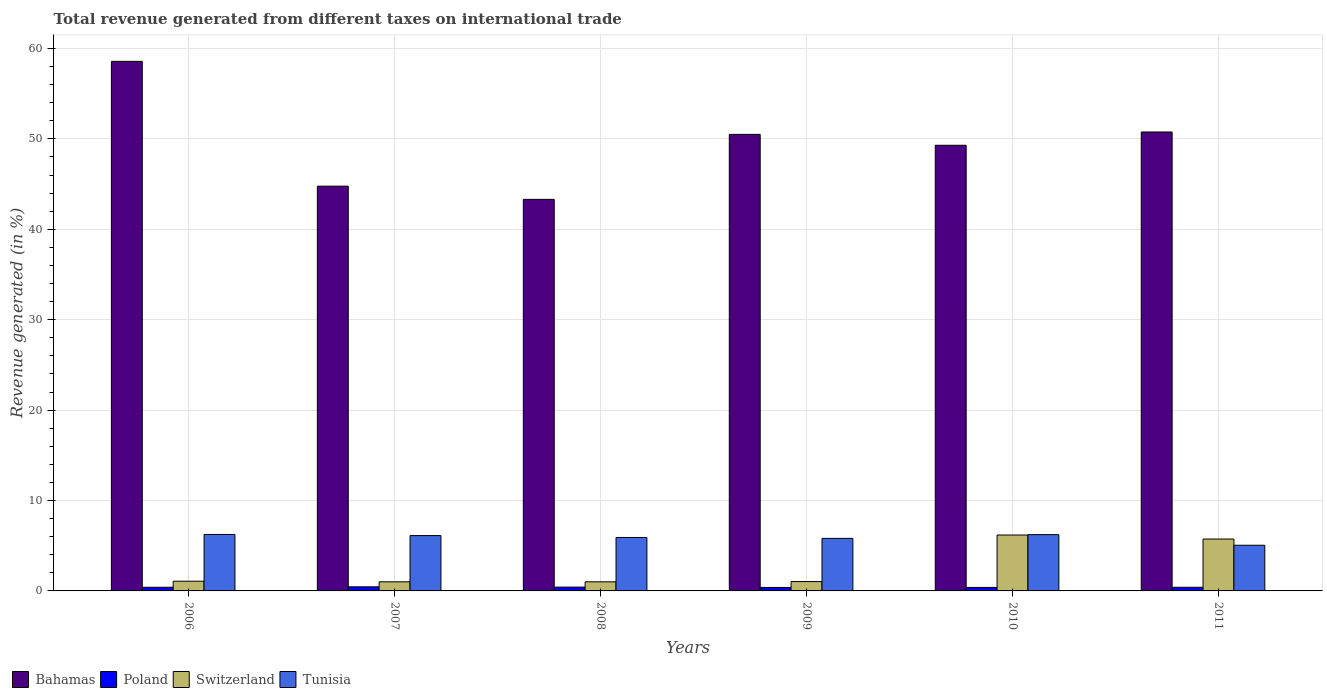How many groups of bars are there?
Your response must be concise. 6. What is the label of the 1st group of bars from the left?
Provide a short and direct response. 2006. In how many cases, is the number of bars for a given year not equal to the number of legend labels?
Give a very brief answer. 0. What is the total revenue generated in Switzerland in 2009?
Provide a succinct answer. 1.04. Across all years, what is the maximum total revenue generated in Bahamas?
Keep it short and to the point. 58.58. Across all years, what is the minimum total revenue generated in Bahamas?
Offer a very short reply. 43.31. In which year was the total revenue generated in Poland maximum?
Your response must be concise. 2007. In which year was the total revenue generated in Tunisia minimum?
Offer a terse response. 2011. What is the total total revenue generated in Poland in the graph?
Your answer should be very brief. 2.45. What is the difference between the total revenue generated in Bahamas in 2007 and that in 2008?
Your answer should be compact. 1.46. What is the difference between the total revenue generated in Bahamas in 2008 and the total revenue generated in Tunisia in 2010?
Keep it short and to the point. 37.09. What is the average total revenue generated in Bahamas per year?
Provide a succinct answer. 49.54. In the year 2009, what is the difference between the total revenue generated in Tunisia and total revenue generated in Switzerland?
Ensure brevity in your answer.  4.77. What is the ratio of the total revenue generated in Tunisia in 2010 to that in 2011?
Keep it short and to the point. 1.23. Is the total revenue generated in Poland in 2010 less than that in 2011?
Provide a short and direct response. Yes. What is the difference between the highest and the second highest total revenue generated in Poland?
Keep it short and to the point. 0.03. What is the difference between the highest and the lowest total revenue generated in Bahamas?
Offer a very short reply. 15.27. In how many years, is the total revenue generated in Switzerland greater than the average total revenue generated in Switzerland taken over all years?
Ensure brevity in your answer.  2. Is it the case that in every year, the sum of the total revenue generated in Switzerland and total revenue generated in Bahamas is greater than the sum of total revenue generated in Tunisia and total revenue generated in Poland?
Offer a very short reply. Yes. What does the 1st bar from the right in 2006 represents?
Keep it short and to the point. Tunisia. Is it the case that in every year, the sum of the total revenue generated in Tunisia and total revenue generated in Poland is greater than the total revenue generated in Bahamas?
Your answer should be compact. No. How many bars are there?
Your response must be concise. 24. Are all the bars in the graph horizontal?
Your response must be concise. No. How many years are there in the graph?
Your response must be concise. 6. What is the difference between two consecutive major ticks on the Y-axis?
Provide a short and direct response. 10. Are the values on the major ticks of Y-axis written in scientific E-notation?
Ensure brevity in your answer.  No. Does the graph contain grids?
Ensure brevity in your answer.  Yes. Where does the legend appear in the graph?
Your answer should be compact. Bottom left. How many legend labels are there?
Provide a short and direct response. 4. How are the legend labels stacked?
Keep it short and to the point. Horizontal. What is the title of the graph?
Provide a succinct answer. Total revenue generated from different taxes on international trade. What is the label or title of the Y-axis?
Your response must be concise. Revenue generated (in %). What is the Revenue generated (in %) in Bahamas in 2006?
Make the answer very short. 58.58. What is the Revenue generated (in %) of Poland in 2006?
Keep it short and to the point. 0.4. What is the Revenue generated (in %) in Switzerland in 2006?
Make the answer very short. 1.07. What is the Revenue generated (in %) in Tunisia in 2006?
Offer a terse response. 6.25. What is the Revenue generated (in %) of Bahamas in 2007?
Give a very brief answer. 44.77. What is the Revenue generated (in %) in Poland in 2007?
Provide a succinct answer. 0.45. What is the Revenue generated (in %) of Switzerland in 2007?
Ensure brevity in your answer.  1.01. What is the Revenue generated (in %) of Tunisia in 2007?
Make the answer very short. 6.12. What is the Revenue generated (in %) of Bahamas in 2008?
Provide a short and direct response. 43.31. What is the Revenue generated (in %) of Poland in 2008?
Your answer should be very brief. 0.42. What is the Revenue generated (in %) in Switzerland in 2008?
Your response must be concise. 1.01. What is the Revenue generated (in %) in Tunisia in 2008?
Your answer should be compact. 5.91. What is the Revenue generated (in %) of Bahamas in 2009?
Make the answer very short. 50.5. What is the Revenue generated (in %) in Poland in 2009?
Offer a terse response. 0.38. What is the Revenue generated (in %) in Switzerland in 2009?
Keep it short and to the point. 1.04. What is the Revenue generated (in %) in Tunisia in 2009?
Provide a succinct answer. 5.81. What is the Revenue generated (in %) in Bahamas in 2010?
Offer a terse response. 49.29. What is the Revenue generated (in %) in Poland in 2010?
Ensure brevity in your answer.  0.39. What is the Revenue generated (in %) in Switzerland in 2010?
Offer a terse response. 6.18. What is the Revenue generated (in %) of Tunisia in 2010?
Ensure brevity in your answer.  6.23. What is the Revenue generated (in %) in Bahamas in 2011?
Offer a terse response. 50.76. What is the Revenue generated (in %) of Poland in 2011?
Your response must be concise. 0.4. What is the Revenue generated (in %) in Switzerland in 2011?
Offer a very short reply. 5.74. What is the Revenue generated (in %) in Tunisia in 2011?
Keep it short and to the point. 5.05. Across all years, what is the maximum Revenue generated (in %) in Bahamas?
Your response must be concise. 58.58. Across all years, what is the maximum Revenue generated (in %) in Poland?
Offer a very short reply. 0.45. Across all years, what is the maximum Revenue generated (in %) in Switzerland?
Make the answer very short. 6.18. Across all years, what is the maximum Revenue generated (in %) in Tunisia?
Provide a short and direct response. 6.25. Across all years, what is the minimum Revenue generated (in %) of Bahamas?
Give a very brief answer. 43.31. Across all years, what is the minimum Revenue generated (in %) in Poland?
Make the answer very short. 0.38. Across all years, what is the minimum Revenue generated (in %) in Switzerland?
Provide a short and direct response. 1.01. Across all years, what is the minimum Revenue generated (in %) of Tunisia?
Offer a terse response. 5.05. What is the total Revenue generated (in %) of Bahamas in the graph?
Offer a very short reply. 297.22. What is the total Revenue generated (in %) in Poland in the graph?
Offer a very short reply. 2.45. What is the total Revenue generated (in %) of Switzerland in the graph?
Give a very brief answer. 16.05. What is the total Revenue generated (in %) of Tunisia in the graph?
Provide a short and direct response. 35.37. What is the difference between the Revenue generated (in %) of Bahamas in 2006 and that in 2007?
Ensure brevity in your answer.  13.81. What is the difference between the Revenue generated (in %) of Poland in 2006 and that in 2007?
Your response must be concise. -0.05. What is the difference between the Revenue generated (in %) of Switzerland in 2006 and that in 2007?
Give a very brief answer. 0.07. What is the difference between the Revenue generated (in %) in Tunisia in 2006 and that in 2007?
Your response must be concise. 0.13. What is the difference between the Revenue generated (in %) in Bahamas in 2006 and that in 2008?
Provide a succinct answer. 15.27. What is the difference between the Revenue generated (in %) in Poland in 2006 and that in 2008?
Ensure brevity in your answer.  -0.02. What is the difference between the Revenue generated (in %) in Switzerland in 2006 and that in 2008?
Offer a very short reply. 0.07. What is the difference between the Revenue generated (in %) in Tunisia in 2006 and that in 2008?
Ensure brevity in your answer.  0.33. What is the difference between the Revenue generated (in %) in Bahamas in 2006 and that in 2009?
Your response must be concise. 8.08. What is the difference between the Revenue generated (in %) in Poland in 2006 and that in 2009?
Provide a short and direct response. 0.02. What is the difference between the Revenue generated (in %) of Switzerland in 2006 and that in 2009?
Provide a short and direct response. 0.04. What is the difference between the Revenue generated (in %) in Tunisia in 2006 and that in 2009?
Make the answer very short. 0.44. What is the difference between the Revenue generated (in %) in Bahamas in 2006 and that in 2010?
Your answer should be compact. 9.28. What is the difference between the Revenue generated (in %) in Poland in 2006 and that in 2010?
Make the answer very short. 0.02. What is the difference between the Revenue generated (in %) of Switzerland in 2006 and that in 2010?
Ensure brevity in your answer.  -5.11. What is the difference between the Revenue generated (in %) in Tunisia in 2006 and that in 2010?
Make the answer very short. 0.02. What is the difference between the Revenue generated (in %) in Bahamas in 2006 and that in 2011?
Make the answer very short. 7.81. What is the difference between the Revenue generated (in %) of Switzerland in 2006 and that in 2011?
Ensure brevity in your answer.  -4.67. What is the difference between the Revenue generated (in %) in Tunisia in 2006 and that in 2011?
Give a very brief answer. 1.2. What is the difference between the Revenue generated (in %) of Bahamas in 2007 and that in 2008?
Ensure brevity in your answer.  1.46. What is the difference between the Revenue generated (in %) in Poland in 2007 and that in 2008?
Make the answer very short. 0.03. What is the difference between the Revenue generated (in %) in Tunisia in 2007 and that in 2008?
Your response must be concise. 0.21. What is the difference between the Revenue generated (in %) of Bahamas in 2007 and that in 2009?
Your answer should be compact. -5.73. What is the difference between the Revenue generated (in %) in Poland in 2007 and that in 2009?
Keep it short and to the point. 0.07. What is the difference between the Revenue generated (in %) in Switzerland in 2007 and that in 2009?
Your answer should be very brief. -0.03. What is the difference between the Revenue generated (in %) of Tunisia in 2007 and that in 2009?
Your response must be concise. 0.31. What is the difference between the Revenue generated (in %) in Bahamas in 2007 and that in 2010?
Offer a terse response. -4.52. What is the difference between the Revenue generated (in %) of Poland in 2007 and that in 2010?
Your answer should be very brief. 0.07. What is the difference between the Revenue generated (in %) in Switzerland in 2007 and that in 2010?
Offer a very short reply. -5.17. What is the difference between the Revenue generated (in %) of Tunisia in 2007 and that in 2010?
Make the answer very short. -0.1. What is the difference between the Revenue generated (in %) of Bahamas in 2007 and that in 2011?
Offer a terse response. -5.99. What is the difference between the Revenue generated (in %) of Poland in 2007 and that in 2011?
Your answer should be very brief. 0.05. What is the difference between the Revenue generated (in %) in Switzerland in 2007 and that in 2011?
Provide a succinct answer. -4.73. What is the difference between the Revenue generated (in %) of Tunisia in 2007 and that in 2011?
Offer a very short reply. 1.07. What is the difference between the Revenue generated (in %) in Bahamas in 2008 and that in 2009?
Provide a succinct answer. -7.19. What is the difference between the Revenue generated (in %) of Poland in 2008 and that in 2009?
Ensure brevity in your answer.  0.04. What is the difference between the Revenue generated (in %) of Switzerland in 2008 and that in 2009?
Offer a terse response. -0.03. What is the difference between the Revenue generated (in %) of Tunisia in 2008 and that in 2009?
Make the answer very short. 0.1. What is the difference between the Revenue generated (in %) of Bahamas in 2008 and that in 2010?
Keep it short and to the point. -5.98. What is the difference between the Revenue generated (in %) in Poland in 2008 and that in 2010?
Your answer should be very brief. 0.03. What is the difference between the Revenue generated (in %) of Switzerland in 2008 and that in 2010?
Provide a short and direct response. -5.17. What is the difference between the Revenue generated (in %) in Tunisia in 2008 and that in 2010?
Provide a succinct answer. -0.31. What is the difference between the Revenue generated (in %) of Bahamas in 2008 and that in 2011?
Provide a short and direct response. -7.45. What is the difference between the Revenue generated (in %) in Poland in 2008 and that in 2011?
Provide a short and direct response. 0.02. What is the difference between the Revenue generated (in %) in Switzerland in 2008 and that in 2011?
Keep it short and to the point. -4.73. What is the difference between the Revenue generated (in %) of Tunisia in 2008 and that in 2011?
Your answer should be compact. 0.86. What is the difference between the Revenue generated (in %) in Bahamas in 2009 and that in 2010?
Your answer should be compact. 1.21. What is the difference between the Revenue generated (in %) in Poland in 2009 and that in 2010?
Ensure brevity in your answer.  -0. What is the difference between the Revenue generated (in %) in Switzerland in 2009 and that in 2010?
Keep it short and to the point. -5.15. What is the difference between the Revenue generated (in %) of Tunisia in 2009 and that in 2010?
Provide a succinct answer. -0.41. What is the difference between the Revenue generated (in %) in Bahamas in 2009 and that in 2011?
Your response must be concise. -0.26. What is the difference between the Revenue generated (in %) of Poland in 2009 and that in 2011?
Your response must be concise. -0.02. What is the difference between the Revenue generated (in %) in Switzerland in 2009 and that in 2011?
Offer a very short reply. -4.7. What is the difference between the Revenue generated (in %) of Tunisia in 2009 and that in 2011?
Your response must be concise. 0.76. What is the difference between the Revenue generated (in %) of Bahamas in 2010 and that in 2011?
Your answer should be very brief. -1.47. What is the difference between the Revenue generated (in %) in Poland in 2010 and that in 2011?
Make the answer very short. -0.02. What is the difference between the Revenue generated (in %) of Switzerland in 2010 and that in 2011?
Your answer should be compact. 0.44. What is the difference between the Revenue generated (in %) of Tunisia in 2010 and that in 2011?
Provide a succinct answer. 1.17. What is the difference between the Revenue generated (in %) of Bahamas in 2006 and the Revenue generated (in %) of Poland in 2007?
Provide a succinct answer. 58.13. What is the difference between the Revenue generated (in %) in Bahamas in 2006 and the Revenue generated (in %) in Switzerland in 2007?
Offer a very short reply. 57.57. What is the difference between the Revenue generated (in %) of Bahamas in 2006 and the Revenue generated (in %) of Tunisia in 2007?
Your response must be concise. 52.46. What is the difference between the Revenue generated (in %) of Poland in 2006 and the Revenue generated (in %) of Switzerland in 2007?
Your answer should be compact. -0.61. What is the difference between the Revenue generated (in %) of Poland in 2006 and the Revenue generated (in %) of Tunisia in 2007?
Your answer should be very brief. -5.72. What is the difference between the Revenue generated (in %) of Switzerland in 2006 and the Revenue generated (in %) of Tunisia in 2007?
Give a very brief answer. -5.05. What is the difference between the Revenue generated (in %) of Bahamas in 2006 and the Revenue generated (in %) of Poland in 2008?
Your answer should be very brief. 58.16. What is the difference between the Revenue generated (in %) in Bahamas in 2006 and the Revenue generated (in %) in Switzerland in 2008?
Provide a short and direct response. 57.57. What is the difference between the Revenue generated (in %) in Bahamas in 2006 and the Revenue generated (in %) in Tunisia in 2008?
Your answer should be compact. 52.66. What is the difference between the Revenue generated (in %) of Poland in 2006 and the Revenue generated (in %) of Switzerland in 2008?
Ensure brevity in your answer.  -0.6. What is the difference between the Revenue generated (in %) of Poland in 2006 and the Revenue generated (in %) of Tunisia in 2008?
Make the answer very short. -5.51. What is the difference between the Revenue generated (in %) in Switzerland in 2006 and the Revenue generated (in %) in Tunisia in 2008?
Your answer should be very brief. -4.84. What is the difference between the Revenue generated (in %) in Bahamas in 2006 and the Revenue generated (in %) in Poland in 2009?
Your answer should be compact. 58.19. What is the difference between the Revenue generated (in %) in Bahamas in 2006 and the Revenue generated (in %) in Switzerland in 2009?
Offer a terse response. 57.54. What is the difference between the Revenue generated (in %) of Bahamas in 2006 and the Revenue generated (in %) of Tunisia in 2009?
Offer a terse response. 52.77. What is the difference between the Revenue generated (in %) of Poland in 2006 and the Revenue generated (in %) of Switzerland in 2009?
Offer a terse response. -0.63. What is the difference between the Revenue generated (in %) of Poland in 2006 and the Revenue generated (in %) of Tunisia in 2009?
Offer a terse response. -5.41. What is the difference between the Revenue generated (in %) in Switzerland in 2006 and the Revenue generated (in %) in Tunisia in 2009?
Make the answer very short. -4.74. What is the difference between the Revenue generated (in %) of Bahamas in 2006 and the Revenue generated (in %) of Poland in 2010?
Ensure brevity in your answer.  58.19. What is the difference between the Revenue generated (in %) in Bahamas in 2006 and the Revenue generated (in %) in Switzerland in 2010?
Your answer should be very brief. 52.39. What is the difference between the Revenue generated (in %) in Bahamas in 2006 and the Revenue generated (in %) in Tunisia in 2010?
Ensure brevity in your answer.  52.35. What is the difference between the Revenue generated (in %) in Poland in 2006 and the Revenue generated (in %) in Switzerland in 2010?
Provide a succinct answer. -5.78. What is the difference between the Revenue generated (in %) of Poland in 2006 and the Revenue generated (in %) of Tunisia in 2010?
Provide a succinct answer. -5.82. What is the difference between the Revenue generated (in %) of Switzerland in 2006 and the Revenue generated (in %) of Tunisia in 2010?
Make the answer very short. -5.15. What is the difference between the Revenue generated (in %) in Bahamas in 2006 and the Revenue generated (in %) in Poland in 2011?
Offer a terse response. 58.17. What is the difference between the Revenue generated (in %) of Bahamas in 2006 and the Revenue generated (in %) of Switzerland in 2011?
Your response must be concise. 52.84. What is the difference between the Revenue generated (in %) in Bahamas in 2006 and the Revenue generated (in %) in Tunisia in 2011?
Keep it short and to the point. 53.53. What is the difference between the Revenue generated (in %) in Poland in 2006 and the Revenue generated (in %) in Switzerland in 2011?
Your response must be concise. -5.34. What is the difference between the Revenue generated (in %) of Poland in 2006 and the Revenue generated (in %) of Tunisia in 2011?
Offer a very short reply. -4.65. What is the difference between the Revenue generated (in %) in Switzerland in 2006 and the Revenue generated (in %) in Tunisia in 2011?
Give a very brief answer. -3.98. What is the difference between the Revenue generated (in %) of Bahamas in 2007 and the Revenue generated (in %) of Poland in 2008?
Provide a short and direct response. 44.35. What is the difference between the Revenue generated (in %) of Bahamas in 2007 and the Revenue generated (in %) of Switzerland in 2008?
Offer a terse response. 43.76. What is the difference between the Revenue generated (in %) in Bahamas in 2007 and the Revenue generated (in %) in Tunisia in 2008?
Keep it short and to the point. 38.86. What is the difference between the Revenue generated (in %) of Poland in 2007 and the Revenue generated (in %) of Switzerland in 2008?
Ensure brevity in your answer.  -0.56. What is the difference between the Revenue generated (in %) of Poland in 2007 and the Revenue generated (in %) of Tunisia in 2008?
Your answer should be very brief. -5.46. What is the difference between the Revenue generated (in %) of Switzerland in 2007 and the Revenue generated (in %) of Tunisia in 2008?
Ensure brevity in your answer.  -4.91. What is the difference between the Revenue generated (in %) of Bahamas in 2007 and the Revenue generated (in %) of Poland in 2009?
Your answer should be very brief. 44.39. What is the difference between the Revenue generated (in %) of Bahamas in 2007 and the Revenue generated (in %) of Switzerland in 2009?
Offer a terse response. 43.73. What is the difference between the Revenue generated (in %) of Bahamas in 2007 and the Revenue generated (in %) of Tunisia in 2009?
Your answer should be compact. 38.96. What is the difference between the Revenue generated (in %) in Poland in 2007 and the Revenue generated (in %) in Switzerland in 2009?
Give a very brief answer. -0.58. What is the difference between the Revenue generated (in %) in Poland in 2007 and the Revenue generated (in %) in Tunisia in 2009?
Make the answer very short. -5.36. What is the difference between the Revenue generated (in %) in Switzerland in 2007 and the Revenue generated (in %) in Tunisia in 2009?
Keep it short and to the point. -4.8. What is the difference between the Revenue generated (in %) of Bahamas in 2007 and the Revenue generated (in %) of Poland in 2010?
Your answer should be compact. 44.39. What is the difference between the Revenue generated (in %) of Bahamas in 2007 and the Revenue generated (in %) of Switzerland in 2010?
Your answer should be compact. 38.59. What is the difference between the Revenue generated (in %) in Bahamas in 2007 and the Revenue generated (in %) in Tunisia in 2010?
Your answer should be compact. 38.55. What is the difference between the Revenue generated (in %) in Poland in 2007 and the Revenue generated (in %) in Switzerland in 2010?
Your answer should be very brief. -5.73. What is the difference between the Revenue generated (in %) of Poland in 2007 and the Revenue generated (in %) of Tunisia in 2010?
Make the answer very short. -5.77. What is the difference between the Revenue generated (in %) in Switzerland in 2007 and the Revenue generated (in %) in Tunisia in 2010?
Make the answer very short. -5.22. What is the difference between the Revenue generated (in %) of Bahamas in 2007 and the Revenue generated (in %) of Poland in 2011?
Provide a succinct answer. 44.37. What is the difference between the Revenue generated (in %) in Bahamas in 2007 and the Revenue generated (in %) in Switzerland in 2011?
Your response must be concise. 39.03. What is the difference between the Revenue generated (in %) in Bahamas in 2007 and the Revenue generated (in %) in Tunisia in 2011?
Your response must be concise. 39.72. What is the difference between the Revenue generated (in %) of Poland in 2007 and the Revenue generated (in %) of Switzerland in 2011?
Offer a very short reply. -5.29. What is the difference between the Revenue generated (in %) of Switzerland in 2007 and the Revenue generated (in %) of Tunisia in 2011?
Ensure brevity in your answer.  -4.04. What is the difference between the Revenue generated (in %) of Bahamas in 2008 and the Revenue generated (in %) of Poland in 2009?
Your answer should be very brief. 42.93. What is the difference between the Revenue generated (in %) of Bahamas in 2008 and the Revenue generated (in %) of Switzerland in 2009?
Keep it short and to the point. 42.28. What is the difference between the Revenue generated (in %) of Bahamas in 2008 and the Revenue generated (in %) of Tunisia in 2009?
Ensure brevity in your answer.  37.5. What is the difference between the Revenue generated (in %) of Poland in 2008 and the Revenue generated (in %) of Switzerland in 2009?
Offer a very short reply. -0.62. What is the difference between the Revenue generated (in %) in Poland in 2008 and the Revenue generated (in %) in Tunisia in 2009?
Offer a very short reply. -5.39. What is the difference between the Revenue generated (in %) of Switzerland in 2008 and the Revenue generated (in %) of Tunisia in 2009?
Ensure brevity in your answer.  -4.8. What is the difference between the Revenue generated (in %) in Bahamas in 2008 and the Revenue generated (in %) in Poland in 2010?
Your response must be concise. 42.93. What is the difference between the Revenue generated (in %) in Bahamas in 2008 and the Revenue generated (in %) in Switzerland in 2010?
Your answer should be very brief. 37.13. What is the difference between the Revenue generated (in %) in Bahamas in 2008 and the Revenue generated (in %) in Tunisia in 2010?
Your answer should be very brief. 37.09. What is the difference between the Revenue generated (in %) in Poland in 2008 and the Revenue generated (in %) in Switzerland in 2010?
Keep it short and to the point. -5.76. What is the difference between the Revenue generated (in %) of Poland in 2008 and the Revenue generated (in %) of Tunisia in 2010?
Provide a short and direct response. -5.8. What is the difference between the Revenue generated (in %) in Switzerland in 2008 and the Revenue generated (in %) in Tunisia in 2010?
Offer a very short reply. -5.22. What is the difference between the Revenue generated (in %) of Bahamas in 2008 and the Revenue generated (in %) of Poland in 2011?
Ensure brevity in your answer.  42.91. What is the difference between the Revenue generated (in %) of Bahamas in 2008 and the Revenue generated (in %) of Switzerland in 2011?
Provide a short and direct response. 37.57. What is the difference between the Revenue generated (in %) in Bahamas in 2008 and the Revenue generated (in %) in Tunisia in 2011?
Your answer should be very brief. 38.26. What is the difference between the Revenue generated (in %) in Poland in 2008 and the Revenue generated (in %) in Switzerland in 2011?
Offer a terse response. -5.32. What is the difference between the Revenue generated (in %) of Poland in 2008 and the Revenue generated (in %) of Tunisia in 2011?
Offer a very short reply. -4.63. What is the difference between the Revenue generated (in %) in Switzerland in 2008 and the Revenue generated (in %) in Tunisia in 2011?
Your response must be concise. -4.04. What is the difference between the Revenue generated (in %) of Bahamas in 2009 and the Revenue generated (in %) of Poland in 2010?
Your answer should be very brief. 50.11. What is the difference between the Revenue generated (in %) of Bahamas in 2009 and the Revenue generated (in %) of Switzerland in 2010?
Offer a terse response. 44.32. What is the difference between the Revenue generated (in %) of Bahamas in 2009 and the Revenue generated (in %) of Tunisia in 2010?
Your response must be concise. 44.28. What is the difference between the Revenue generated (in %) of Poland in 2009 and the Revenue generated (in %) of Switzerland in 2010?
Make the answer very short. -5.8. What is the difference between the Revenue generated (in %) in Poland in 2009 and the Revenue generated (in %) in Tunisia in 2010?
Provide a short and direct response. -5.84. What is the difference between the Revenue generated (in %) in Switzerland in 2009 and the Revenue generated (in %) in Tunisia in 2010?
Give a very brief answer. -5.19. What is the difference between the Revenue generated (in %) of Bahamas in 2009 and the Revenue generated (in %) of Poland in 2011?
Provide a succinct answer. 50.1. What is the difference between the Revenue generated (in %) in Bahamas in 2009 and the Revenue generated (in %) in Switzerland in 2011?
Offer a terse response. 44.76. What is the difference between the Revenue generated (in %) of Bahamas in 2009 and the Revenue generated (in %) of Tunisia in 2011?
Ensure brevity in your answer.  45.45. What is the difference between the Revenue generated (in %) of Poland in 2009 and the Revenue generated (in %) of Switzerland in 2011?
Provide a short and direct response. -5.36. What is the difference between the Revenue generated (in %) in Poland in 2009 and the Revenue generated (in %) in Tunisia in 2011?
Your response must be concise. -4.67. What is the difference between the Revenue generated (in %) of Switzerland in 2009 and the Revenue generated (in %) of Tunisia in 2011?
Your answer should be compact. -4.02. What is the difference between the Revenue generated (in %) of Bahamas in 2010 and the Revenue generated (in %) of Poland in 2011?
Offer a terse response. 48.89. What is the difference between the Revenue generated (in %) of Bahamas in 2010 and the Revenue generated (in %) of Switzerland in 2011?
Offer a terse response. 43.55. What is the difference between the Revenue generated (in %) of Bahamas in 2010 and the Revenue generated (in %) of Tunisia in 2011?
Offer a very short reply. 44.24. What is the difference between the Revenue generated (in %) in Poland in 2010 and the Revenue generated (in %) in Switzerland in 2011?
Give a very brief answer. -5.35. What is the difference between the Revenue generated (in %) of Poland in 2010 and the Revenue generated (in %) of Tunisia in 2011?
Offer a very short reply. -4.67. What is the difference between the Revenue generated (in %) of Switzerland in 2010 and the Revenue generated (in %) of Tunisia in 2011?
Provide a succinct answer. 1.13. What is the average Revenue generated (in %) in Bahamas per year?
Your response must be concise. 49.54. What is the average Revenue generated (in %) of Poland per year?
Keep it short and to the point. 0.41. What is the average Revenue generated (in %) of Switzerland per year?
Give a very brief answer. 2.68. What is the average Revenue generated (in %) in Tunisia per year?
Your response must be concise. 5.9. In the year 2006, what is the difference between the Revenue generated (in %) of Bahamas and Revenue generated (in %) of Poland?
Keep it short and to the point. 58.17. In the year 2006, what is the difference between the Revenue generated (in %) in Bahamas and Revenue generated (in %) in Switzerland?
Provide a succinct answer. 57.5. In the year 2006, what is the difference between the Revenue generated (in %) in Bahamas and Revenue generated (in %) in Tunisia?
Ensure brevity in your answer.  52.33. In the year 2006, what is the difference between the Revenue generated (in %) of Poland and Revenue generated (in %) of Switzerland?
Give a very brief answer. -0.67. In the year 2006, what is the difference between the Revenue generated (in %) of Poland and Revenue generated (in %) of Tunisia?
Keep it short and to the point. -5.84. In the year 2006, what is the difference between the Revenue generated (in %) of Switzerland and Revenue generated (in %) of Tunisia?
Give a very brief answer. -5.17. In the year 2007, what is the difference between the Revenue generated (in %) in Bahamas and Revenue generated (in %) in Poland?
Offer a terse response. 44.32. In the year 2007, what is the difference between the Revenue generated (in %) in Bahamas and Revenue generated (in %) in Switzerland?
Make the answer very short. 43.76. In the year 2007, what is the difference between the Revenue generated (in %) of Bahamas and Revenue generated (in %) of Tunisia?
Keep it short and to the point. 38.65. In the year 2007, what is the difference between the Revenue generated (in %) of Poland and Revenue generated (in %) of Switzerland?
Your response must be concise. -0.56. In the year 2007, what is the difference between the Revenue generated (in %) of Poland and Revenue generated (in %) of Tunisia?
Offer a very short reply. -5.67. In the year 2007, what is the difference between the Revenue generated (in %) in Switzerland and Revenue generated (in %) in Tunisia?
Offer a terse response. -5.11. In the year 2008, what is the difference between the Revenue generated (in %) of Bahamas and Revenue generated (in %) of Poland?
Offer a very short reply. 42.89. In the year 2008, what is the difference between the Revenue generated (in %) in Bahamas and Revenue generated (in %) in Switzerland?
Your response must be concise. 42.3. In the year 2008, what is the difference between the Revenue generated (in %) of Bahamas and Revenue generated (in %) of Tunisia?
Offer a terse response. 37.4. In the year 2008, what is the difference between the Revenue generated (in %) in Poland and Revenue generated (in %) in Switzerland?
Ensure brevity in your answer.  -0.59. In the year 2008, what is the difference between the Revenue generated (in %) of Poland and Revenue generated (in %) of Tunisia?
Provide a succinct answer. -5.49. In the year 2008, what is the difference between the Revenue generated (in %) in Switzerland and Revenue generated (in %) in Tunisia?
Keep it short and to the point. -4.91. In the year 2009, what is the difference between the Revenue generated (in %) in Bahamas and Revenue generated (in %) in Poland?
Give a very brief answer. 50.12. In the year 2009, what is the difference between the Revenue generated (in %) in Bahamas and Revenue generated (in %) in Switzerland?
Your answer should be very brief. 49.46. In the year 2009, what is the difference between the Revenue generated (in %) of Bahamas and Revenue generated (in %) of Tunisia?
Provide a short and direct response. 44.69. In the year 2009, what is the difference between the Revenue generated (in %) of Poland and Revenue generated (in %) of Switzerland?
Ensure brevity in your answer.  -0.65. In the year 2009, what is the difference between the Revenue generated (in %) in Poland and Revenue generated (in %) in Tunisia?
Ensure brevity in your answer.  -5.43. In the year 2009, what is the difference between the Revenue generated (in %) in Switzerland and Revenue generated (in %) in Tunisia?
Provide a short and direct response. -4.77. In the year 2010, what is the difference between the Revenue generated (in %) in Bahamas and Revenue generated (in %) in Poland?
Provide a short and direct response. 48.91. In the year 2010, what is the difference between the Revenue generated (in %) in Bahamas and Revenue generated (in %) in Switzerland?
Your response must be concise. 43.11. In the year 2010, what is the difference between the Revenue generated (in %) in Bahamas and Revenue generated (in %) in Tunisia?
Your response must be concise. 43.07. In the year 2010, what is the difference between the Revenue generated (in %) of Poland and Revenue generated (in %) of Switzerland?
Offer a very short reply. -5.8. In the year 2010, what is the difference between the Revenue generated (in %) in Poland and Revenue generated (in %) in Tunisia?
Ensure brevity in your answer.  -5.84. In the year 2010, what is the difference between the Revenue generated (in %) of Switzerland and Revenue generated (in %) of Tunisia?
Your answer should be very brief. -0.04. In the year 2011, what is the difference between the Revenue generated (in %) of Bahamas and Revenue generated (in %) of Poland?
Ensure brevity in your answer.  50.36. In the year 2011, what is the difference between the Revenue generated (in %) of Bahamas and Revenue generated (in %) of Switzerland?
Your answer should be very brief. 45.02. In the year 2011, what is the difference between the Revenue generated (in %) in Bahamas and Revenue generated (in %) in Tunisia?
Ensure brevity in your answer.  45.71. In the year 2011, what is the difference between the Revenue generated (in %) in Poland and Revenue generated (in %) in Switzerland?
Your answer should be very brief. -5.34. In the year 2011, what is the difference between the Revenue generated (in %) in Poland and Revenue generated (in %) in Tunisia?
Your answer should be compact. -4.65. In the year 2011, what is the difference between the Revenue generated (in %) in Switzerland and Revenue generated (in %) in Tunisia?
Provide a short and direct response. 0.69. What is the ratio of the Revenue generated (in %) in Bahamas in 2006 to that in 2007?
Ensure brevity in your answer.  1.31. What is the ratio of the Revenue generated (in %) of Poland in 2006 to that in 2007?
Provide a short and direct response. 0.89. What is the ratio of the Revenue generated (in %) of Switzerland in 2006 to that in 2007?
Keep it short and to the point. 1.06. What is the ratio of the Revenue generated (in %) of Tunisia in 2006 to that in 2007?
Give a very brief answer. 1.02. What is the ratio of the Revenue generated (in %) in Bahamas in 2006 to that in 2008?
Make the answer very short. 1.35. What is the ratio of the Revenue generated (in %) in Poland in 2006 to that in 2008?
Your response must be concise. 0.96. What is the ratio of the Revenue generated (in %) in Switzerland in 2006 to that in 2008?
Keep it short and to the point. 1.07. What is the ratio of the Revenue generated (in %) of Tunisia in 2006 to that in 2008?
Your answer should be compact. 1.06. What is the ratio of the Revenue generated (in %) in Bahamas in 2006 to that in 2009?
Offer a terse response. 1.16. What is the ratio of the Revenue generated (in %) in Poland in 2006 to that in 2009?
Ensure brevity in your answer.  1.05. What is the ratio of the Revenue generated (in %) of Switzerland in 2006 to that in 2009?
Provide a succinct answer. 1.04. What is the ratio of the Revenue generated (in %) of Tunisia in 2006 to that in 2009?
Offer a terse response. 1.08. What is the ratio of the Revenue generated (in %) in Bahamas in 2006 to that in 2010?
Your response must be concise. 1.19. What is the ratio of the Revenue generated (in %) in Poland in 2006 to that in 2010?
Keep it short and to the point. 1.04. What is the ratio of the Revenue generated (in %) in Switzerland in 2006 to that in 2010?
Offer a very short reply. 0.17. What is the ratio of the Revenue generated (in %) of Tunisia in 2006 to that in 2010?
Provide a succinct answer. 1. What is the ratio of the Revenue generated (in %) of Bahamas in 2006 to that in 2011?
Provide a short and direct response. 1.15. What is the ratio of the Revenue generated (in %) of Switzerland in 2006 to that in 2011?
Offer a terse response. 0.19. What is the ratio of the Revenue generated (in %) of Tunisia in 2006 to that in 2011?
Ensure brevity in your answer.  1.24. What is the ratio of the Revenue generated (in %) in Bahamas in 2007 to that in 2008?
Provide a short and direct response. 1.03. What is the ratio of the Revenue generated (in %) in Poland in 2007 to that in 2008?
Make the answer very short. 1.07. What is the ratio of the Revenue generated (in %) of Tunisia in 2007 to that in 2008?
Make the answer very short. 1.04. What is the ratio of the Revenue generated (in %) of Bahamas in 2007 to that in 2009?
Your response must be concise. 0.89. What is the ratio of the Revenue generated (in %) of Poland in 2007 to that in 2009?
Give a very brief answer. 1.17. What is the ratio of the Revenue generated (in %) of Tunisia in 2007 to that in 2009?
Your response must be concise. 1.05. What is the ratio of the Revenue generated (in %) in Bahamas in 2007 to that in 2010?
Keep it short and to the point. 0.91. What is the ratio of the Revenue generated (in %) in Poland in 2007 to that in 2010?
Your response must be concise. 1.17. What is the ratio of the Revenue generated (in %) in Switzerland in 2007 to that in 2010?
Your answer should be very brief. 0.16. What is the ratio of the Revenue generated (in %) in Tunisia in 2007 to that in 2010?
Your answer should be compact. 0.98. What is the ratio of the Revenue generated (in %) of Bahamas in 2007 to that in 2011?
Offer a very short reply. 0.88. What is the ratio of the Revenue generated (in %) in Poland in 2007 to that in 2011?
Your response must be concise. 1.12. What is the ratio of the Revenue generated (in %) of Switzerland in 2007 to that in 2011?
Keep it short and to the point. 0.18. What is the ratio of the Revenue generated (in %) of Tunisia in 2007 to that in 2011?
Offer a terse response. 1.21. What is the ratio of the Revenue generated (in %) of Bahamas in 2008 to that in 2009?
Your answer should be very brief. 0.86. What is the ratio of the Revenue generated (in %) in Poland in 2008 to that in 2009?
Your response must be concise. 1.09. What is the ratio of the Revenue generated (in %) in Switzerland in 2008 to that in 2009?
Offer a very short reply. 0.97. What is the ratio of the Revenue generated (in %) of Tunisia in 2008 to that in 2009?
Your answer should be compact. 1.02. What is the ratio of the Revenue generated (in %) of Bahamas in 2008 to that in 2010?
Provide a short and direct response. 0.88. What is the ratio of the Revenue generated (in %) in Poland in 2008 to that in 2010?
Your answer should be very brief. 1.09. What is the ratio of the Revenue generated (in %) of Switzerland in 2008 to that in 2010?
Make the answer very short. 0.16. What is the ratio of the Revenue generated (in %) of Tunisia in 2008 to that in 2010?
Your answer should be very brief. 0.95. What is the ratio of the Revenue generated (in %) of Bahamas in 2008 to that in 2011?
Your answer should be compact. 0.85. What is the ratio of the Revenue generated (in %) of Poland in 2008 to that in 2011?
Ensure brevity in your answer.  1.04. What is the ratio of the Revenue generated (in %) of Switzerland in 2008 to that in 2011?
Your answer should be compact. 0.18. What is the ratio of the Revenue generated (in %) of Tunisia in 2008 to that in 2011?
Provide a succinct answer. 1.17. What is the ratio of the Revenue generated (in %) in Bahamas in 2009 to that in 2010?
Ensure brevity in your answer.  1.02. What is the ratio of the Revenue generated (in %) of Poland in 2009 to that in 2010?
Keep it short and to the point. 1. What is the ratio of the Revenue generated (in %) of Switzerland in 2009 to that in 2010?
Offer a very short reply. 0.17. What is the ratio of the Revenue generated (in %) of Tunisia in 2009 to that in 2010?
Your answer should be compact. 0.93. What is the ratio of the Revenue generated (in %) of Poland in 2009 to that in 2011?
Make the answer very short. 0.96. What is the ratio of the Revenue generated (in %) in Switzerland in 2009 to that in 2011?
Your answer should be compact. 0.18. What is the ratio of the Revenue generated (in %) of Tunisia in 2009 to that in 2011?
Your answer should be compact. 1.15. What is the ratio of the Revenue generated (in %) of Bahamas in 2010 to that in 2011?
Give a very brief answer. 0.97. What is the ratio of the Revenue generated (in %) in Poland in 2010 to that in 2011?
Give a very brief answer. 0.96. What is the ratio of the Revenue generated (in %) of Switzerland in 2010 to that in 2011?
Provide a short and direct response. 1.08. What is the ratio of the Revenue generated (in %) in Tunisia in 2010 to that in 2011?
Your answer should be very brief. 1.23. What is the difference between the highest and the second highest Revenue generated (in %) in Bahamas?
Provide a succinct answer. 7.81. What is the difference between the highest and the second highest Revenue generated (in %) of Poland?
Your response must be concise. 0.03. What is the difference between the highest and the second highest Revenue generated (in %) of Switzerland?
Provide a short and direct response. 0.44. What is the difference between the highest and the second highest Revenue generated (in %) of Tunisia?
Make the answer very short. 0.02. What is the difference between the highest and the lowest Revenue generated (in %) of Bahamas?
Your answer should be compact. 15.27. What is the difference between the highest and the lowest Revenue generated (in %) of Poland?
Offer a terse response. 0.07. What is the difference between the highest and the lowest Revenue generated (in %) of Switzerland?
Provide a short and direct response. 5.17. What is the difference between the highest and the lowest Revenue generated (in %) in Tunisia?
Your answer should be compact. 1.2. 